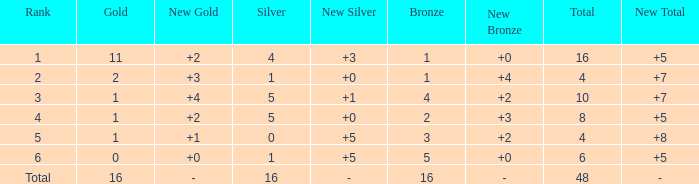What is the total gold that has bronze less than 2, a silver of 1 and total more than 4? None. 